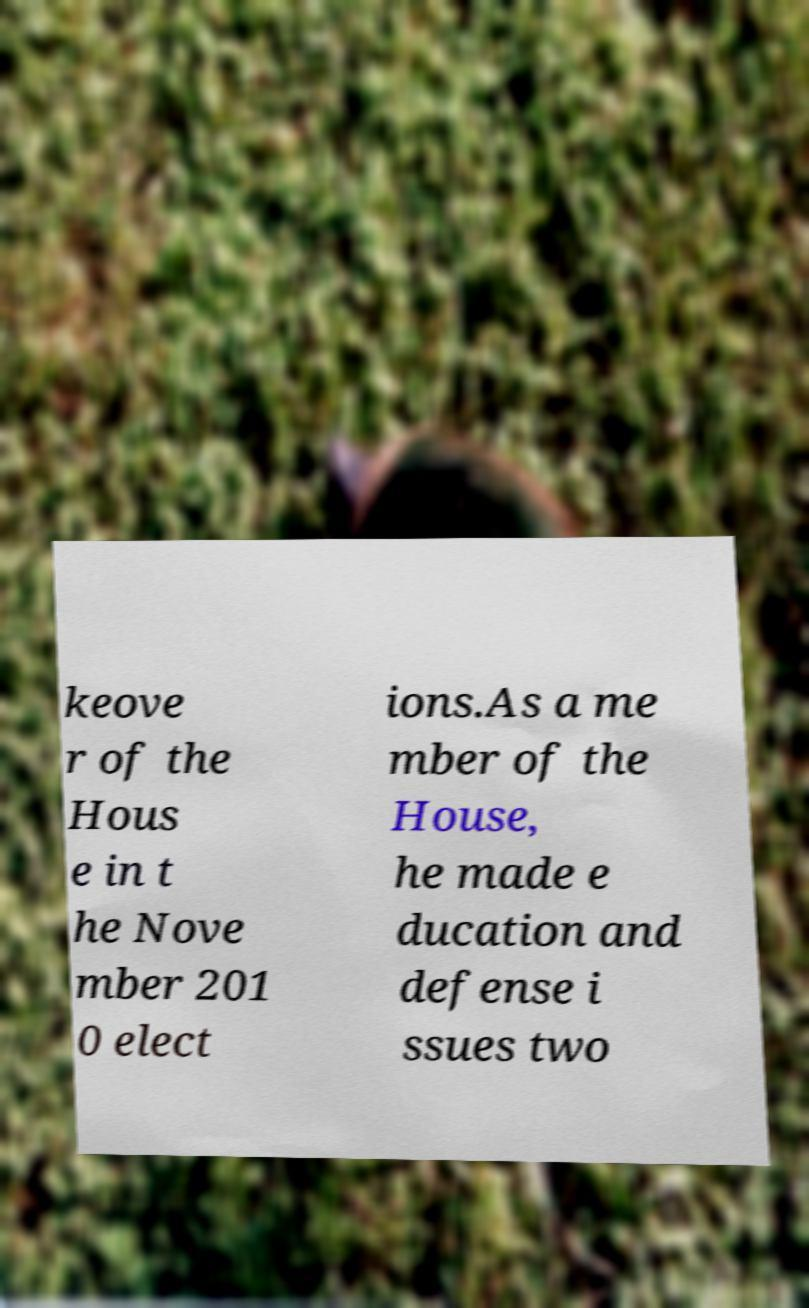Please identify and transcribe the text found in this image. keove r of the Hous e in t he Nove mber 201 0 elect ions.As a me mber of the House, he made e ducation and defense i ssues two 